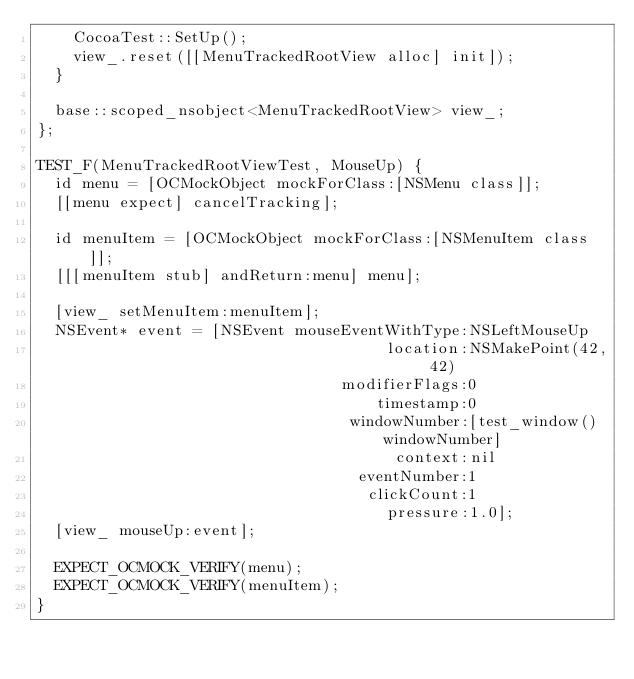<code> <loc_0><loc_0><loc_500><loc_500><_ObjectiveC_>    CocoaTest::SetUp();
    view_.reset([[MenuTrackedRootView alloc] init]);
  }

  base::scoped_nsobject<MenuTrackedRootView> view_;
};

TEST_F(MenuTrackedRootViewTest, MouseUp) {
  id menu = [OCMockObject mockForClass:[NSMenu class]];
  [[menu expect] cancelTracking];

  id menuItem = [OCMockObject mockForClass:[NSMenuItem class]];
  [[[menuItem stub] andReturn:menu] menu];

  [view_ setMenuItem:menuItem];
  NSEvent* event = [NSEvent mouseEventWithType:NSLeftMouseUp
                                      location:NSMakePoint(42, 42)
                                 modifierFlags:0
                                     timestamp:0
                                  windowNumber:[test_window() windowNumber]
                                       context:nil
                                   eventNumber:1
                                    clickCount:1
                                      pressure:1.0];
  [view_ mouseUp:event];

  EXPECT_OCMOCK_VERIFY(menu);
  EXPECT_OCMOCK_VERIFY(menuItem);
}
</code> 